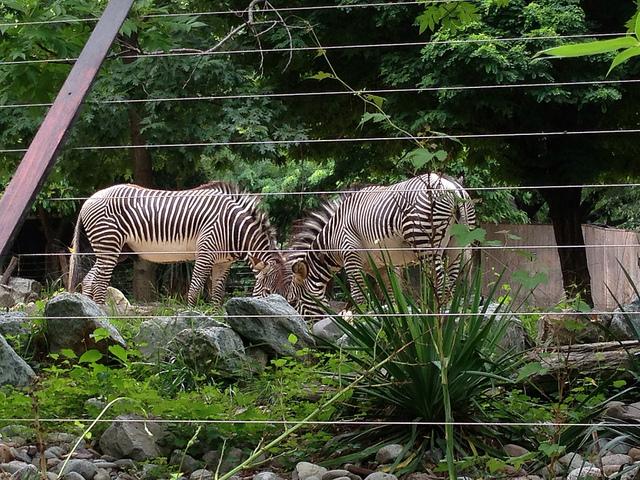Are there any rocks in the picture?
Concise answer only. Yes. Are the zebras facing the same direction?
Quick response, please. No. What is the animal on the right doing?
Be succinct. Eating. From what material is the boundary in the foreground constructed?
Be succinct. Metal. Are those zebras alive?
Quick response, please. Yes. 